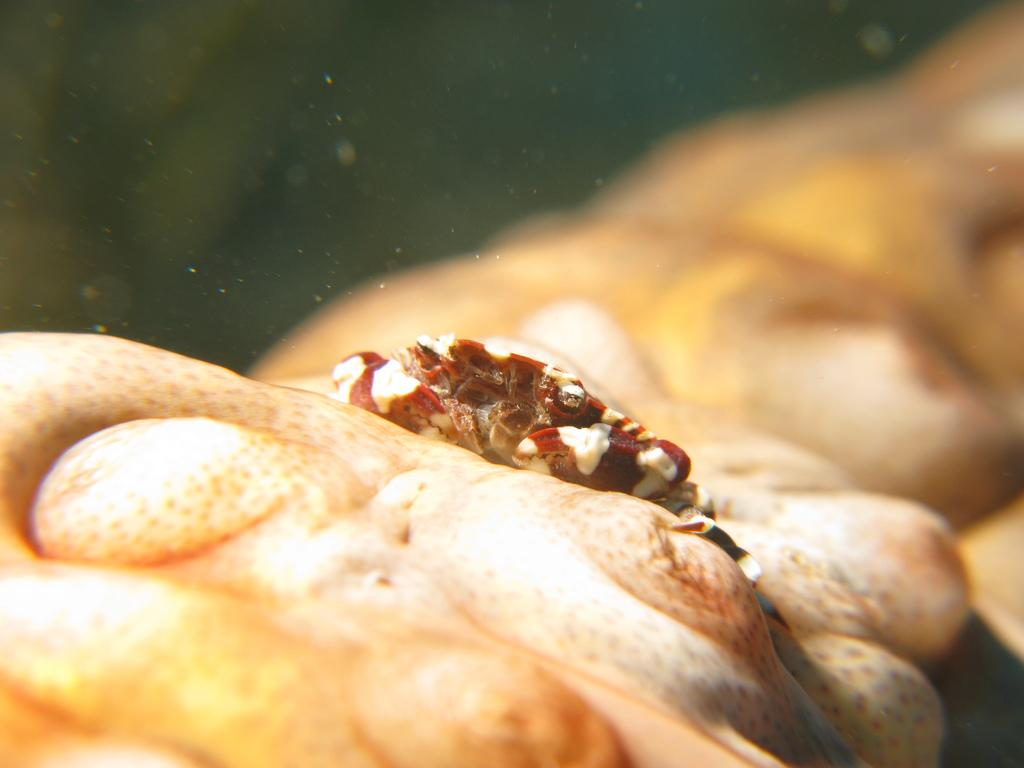What is the red object in the image that resembles a crab? There is a red object in the image that resembles a crab. What is the color of the other object in the image? The other object in the image is cream-colored. Where are both objects located in the image? Both objects are in the water. What type of trees can be seen in the image? There are no trees present in the image; it features two objects in the water. What is the weather like in the image? The provided facts do not mention the weather, so it cannot be determined from the image. 